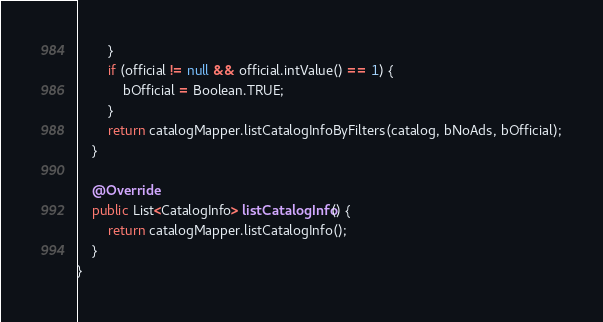<code> <loc_0><loc_0><loc_500><loc_500><_Java_>        }
        if (official != null && official.intValue() == 1) {
            bOfficial = Boolean.TRUE;
        }
        return catalogMapper.listCatalogInfoByFilters(catalog, bNoAds, bOfficial);
    }

    @Override
    public List<CatalogInfo> listCatalogInfo() {
        return catalogMapper.listCatalogInfo();
    }
}
</code> 